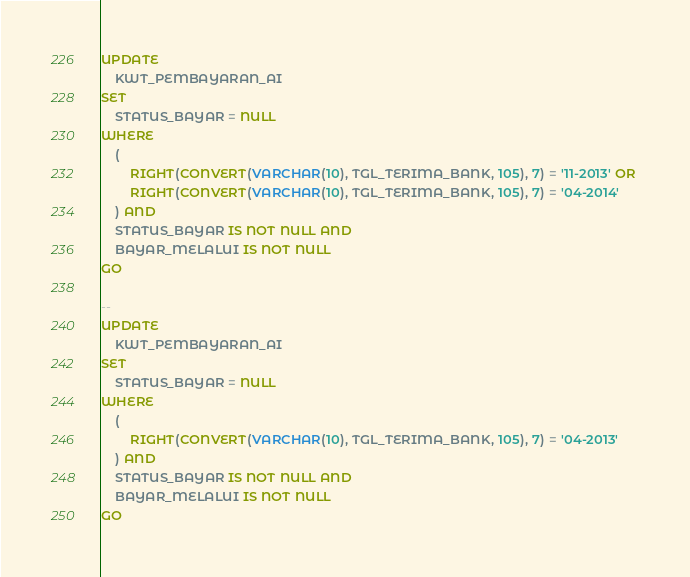<code> <loc_0><loc_0><loc_500><loc_500><_SQL_>UPDATE 
	KWT_PEMBAYARAN_AI
SET 
	STATUS_BAYAR = NULL
WHERE 
	(
		RIGHT(CONVERT(VARCHAR(10), TGL_TERIMA_BANK, 105), 7) = '11-2013' OR 
		RIGHT(CONVERT(VARCHAR(10), TGL_TERIMA_BANK, 105), 7) = '04-2014'
	) AND
	STATUS_BAYAR IS NOT NULL AND 
	BAYAR_MELALUI IS NOT NULL
GO

--
UPDATE 
	KWT_PEMBAYARAN_AI
SET 
	STATUS_BAYAR = NULL
WHERE 
	(
		RIGHT(CONVERT(VARCHAR(10), TGL_TERIMA_BANK, 105), 7) = '04-2013'
	) AND
	STATUS_BAYAR IS NOT NULL AND 
	BAYAR_MELALUI IS NOT NULL
GO</code> 